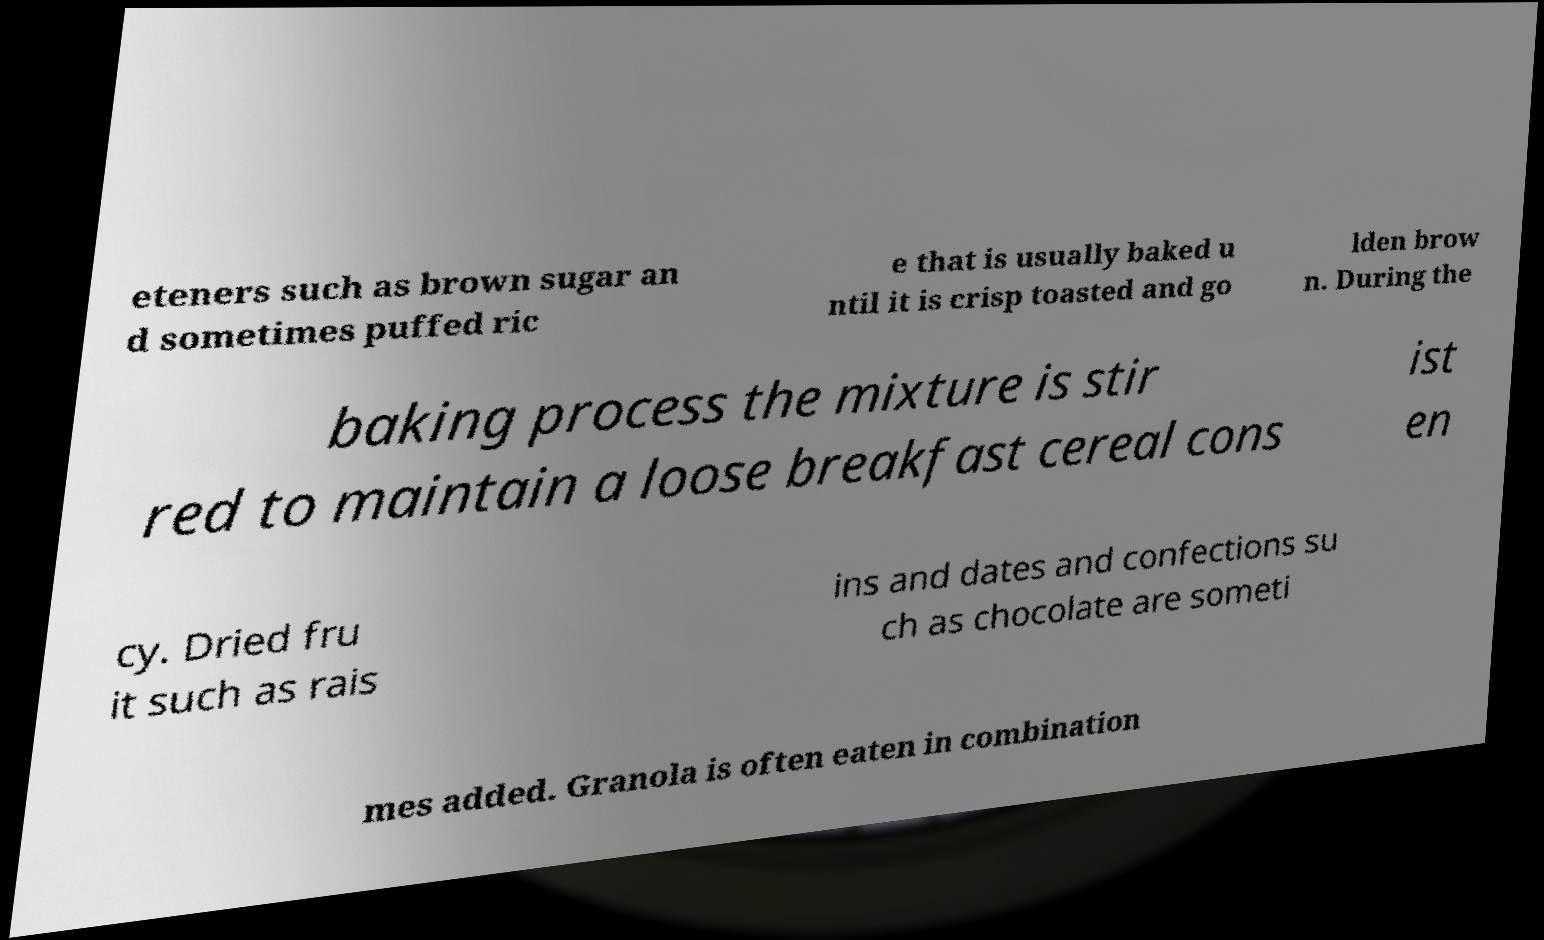I need the written content from this picture converted into text. Can you do that? eteners such as brown sugar an d sometimes puffed ric e that is usually baked u ntil it is crisp toasted and go lden brow n. During the baking process the mixture is stir red to maintain a loose breakfast cereal cons ist en cy. Dried fru it such as rais ins and dates and confections su ch as chocolate are someti mes added. Granola is often eaten in combination 